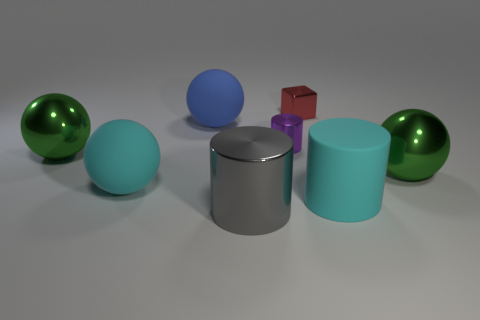Subtract all blue spheres. How many spheres are left? 3 Add 1 big blue things. How many objects exist? 9 Subtract all purple cylinders. How many cylinders are left? 2 Subtract all blocks. How many objects are left? 7 Add 5 small red objects. How many small red objects exist? 6 Subtract 0 blue cylinders. How many objects are left? 8 Subtract 1 cylinders. How many cylinders are left? 2 Subtract all red spheres. Subtract all green blocks. How many spheres are left? 4 Subtract all yellow blocks. How many purple cylinders are left? 1 Subtract all large green metallic things. Subtract all tiny purple shiny things. How many objects are left? 5 